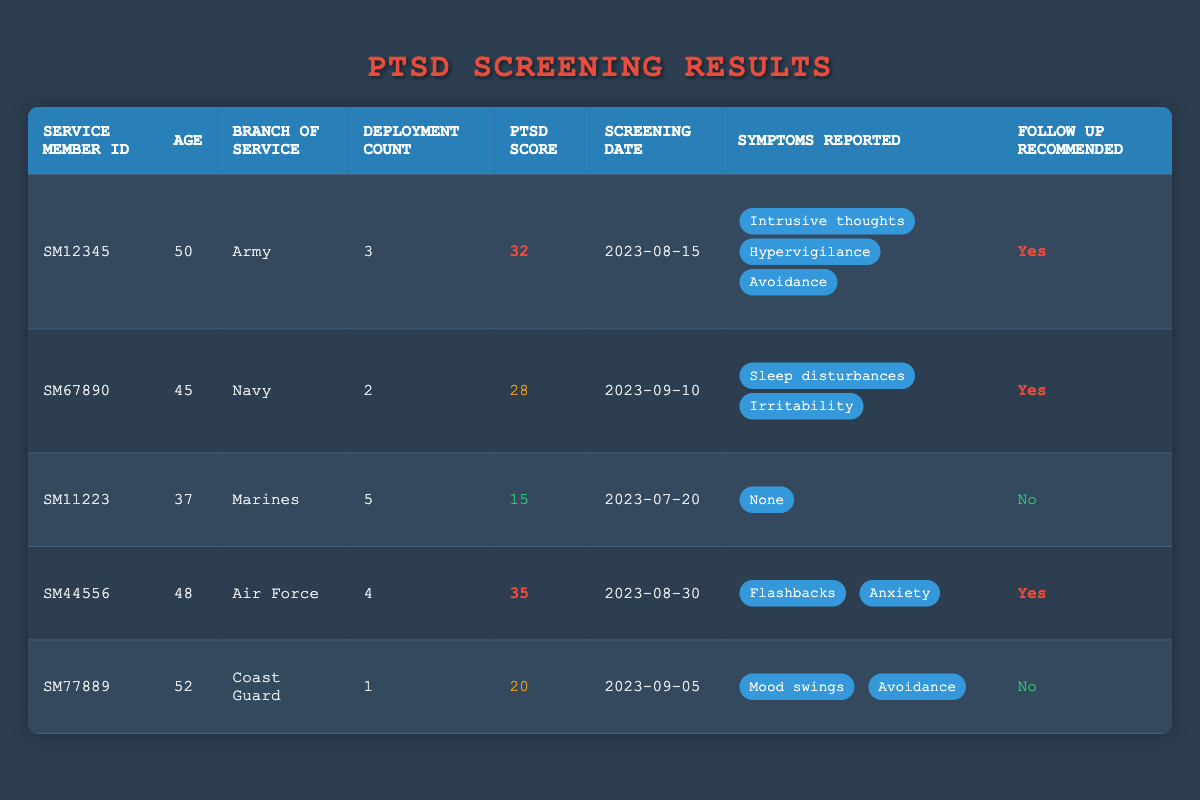What is the PTSD score of the service member with ID SM12345? The table indicates that the PTSD score for service member SM12345 is listed in the "PTSD Score" column, where SM12345 has a score of 32.
Answer: 32 How many service members do not require follow-up? By examining the "Follow Up Recommended" column, we see that service members SM11223 and SM77889 have "No" listed, which sums up to two members.
Answer: 2 What is the average age of the service members in this table? First, we need to sum the ages of all service members: 50 + 45 + 37 + 48 + 52 = 232. Then, we divide by the number of service members, which is 5. Therefore, 232 / 5 = 46.4.
Answer: 46.4 Which branch of service has the highest PTSD score? Reviewing the "Branch of Service" and "PTSD Score" columns, we can see that the highest score is 35, associated with the Air Force (SM44556).
Answer: Air Force How many total deployments do the service members with PTSD scores over 30 have? We look at the PTSD scores and find SM12345 with a score of 32 (3 deployments) and SM44556 with a score of 35 (4 deployments). Adding these, 3 + 4 = 7.
Answer: 7 Is there a service member aged 52 who reported symptoms related to avoidance? Checking the age and symptoms for service member SM77889, we find that he is 52 years old and has reported "Mood swings" and "Avoidance." This means the condition is met.
Answer: Yes What percentage of the service members recommended for follow-up are from the Army? There are two service members who are recommended for follow-up: SM12345 (Army) and SM44556 (Air Force). Only one (SM12345) is from the Army. Therefore, the percentage is (1/2) * 100 = 50%.
Answer: 50% How many service members reported "Sleep disturbances"? By inspecting the "Symptoms Reported" section, only one service member, SM67890 from the Navy, reported "Sleep disturbances."
Answer: 1 